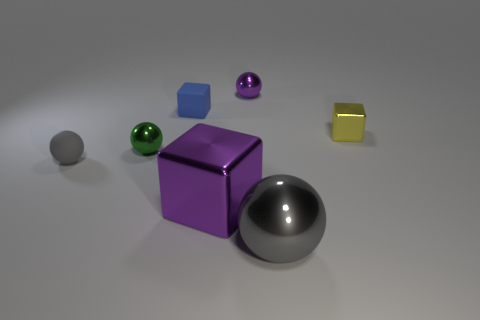Subtract 1 spheres. How many spheres are left? 3 Subtract all green balls. Subtract all cyan cylinders. How many balls are left? 3 Add 1 yellow metal things. How many objects exist? 8 Subtract all balls. How many objects are left? 3 Add 3 big gray metallic objects. How many big gray metallic objects exist? 4 Subtract 0 gray cylinders. How many objects are left? 7 Subtract all brown spheres. Subtract all large gray things. How many objects are left? 6 Add 5 rubber cubes. How many rubber cubes are left? 6 